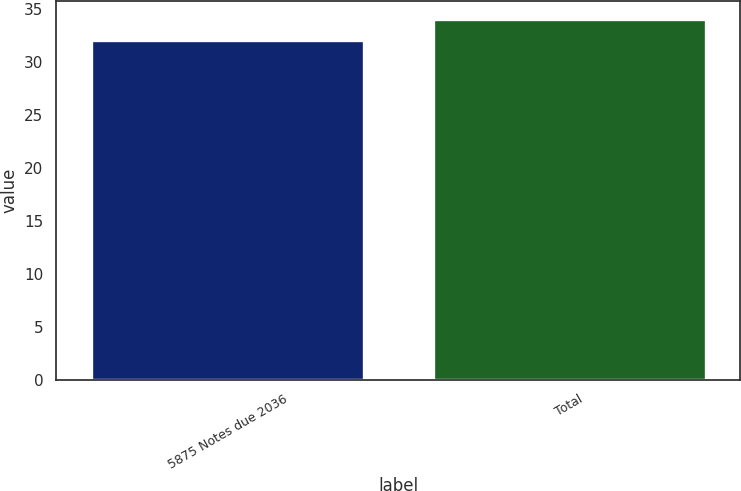Convert chart to OTSL. <chart><loc_0><loc_0><loc_500><loc_500><bar_chart><fcel>5875 Notes due 2036<fcel>Total<nl><fcel>32<fcel>34<nl></chart> 